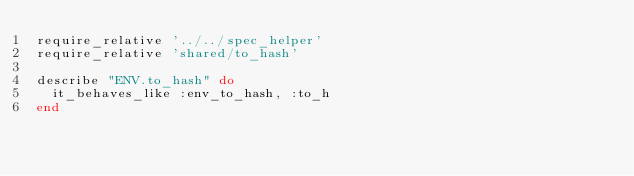<code> <loc_0><loc_0><loc_500><loc_500><_Ruby_>require_relative '../../spec_helper'
require_relative 'shared/to_hash'

describe "ENV.to_hash" do
  it_behaves_like :env_to_hash, :to_h
end
</code> 